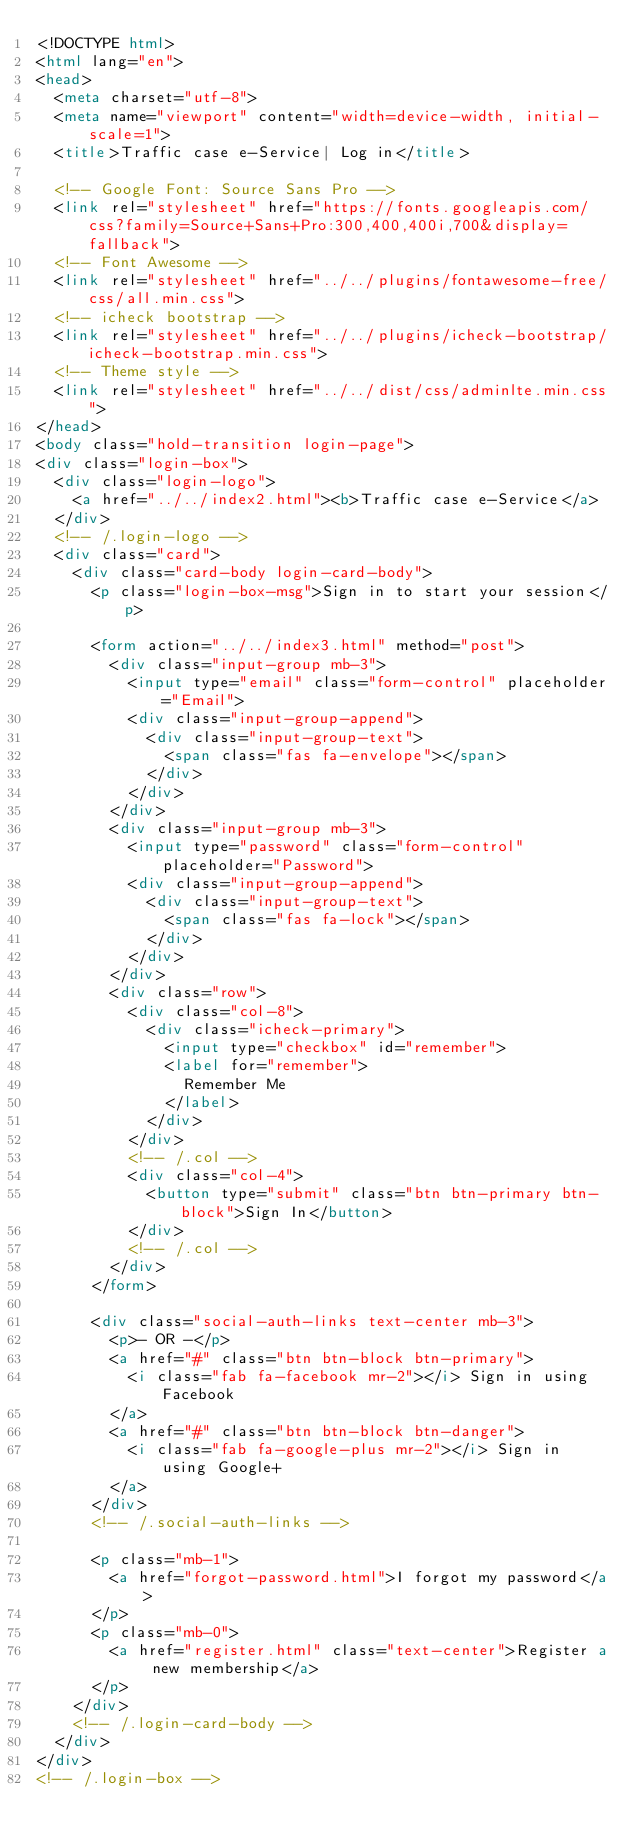<code> <loc_0><loc_0><loc_500><loc_500><_HTML_><!DOCTYPE html>
<html lang="en">
<head>
  <meta charset="utf-8">
  <meta name="viewport" content="width=device-width, initial-scale=1">
  <title>Traffic case e-Service| Log in</title>

  <!-- Google Font: Source Sans Pro -->
  <link rel="stylesheet" href="https://fonts.googleapis.com/css?family=Source+Sans+Pro:300,400,400i,700&display=fallback">
  <!-- Font Awesome -->
  <link rel="stylesheet" href="../../plugins/fontawesome-free/css/all.min.css">
  <!-- icheck bootstrap -->
  <link rel="stylesheet" href="../../plugins/icheck-bootstrap/icheck-bootstrap.min.css">
  <!-- Theme style -->
  <link rel="stylesheet" href="../../dist/css/adminlte.min.css">
</head>
<body class="hold-transition login-page">
<div class="login-box">
  <div class="login-logo">
    <a href="../../index2.html"><b>Traffic case e-Service</a>
  </div>
  <!-- /.login-logo -->
  <div class="card">
    <div class="card-body login-card-body">
      <p class="login-box-msg">Sign in to start your session</p>

      <form action="../../index3.html" method="post">
        <div class="input-group mb-3">
          <input type="email" class="form-control" placeholder="Email">
          <div class="input-group-append">
            <div class="input-group-text">
              <span class="fas fa-envelope"></span>
            </div>
          </div>
        </div>
        <div class="input-group mb-3">
          <input type="password" class="form-control" placeholder="Password">
          <div class="input-group-append">
            <div class="input-group-text">
              <span class="fas fa-lock"></span>
            </div>
          </div>
        </div>
        <div class="row">
          <div class="col-8">
            <div class="icheck-primary">
              <input type="checkbox" id="remember">
              <label for="remember">
                Remember Me
              </label>
            </div>
          </div>
          <!-- /.col -->
          <div class="col-4">
            <button type="submit" class="btn btn-primary btn-block">Sign In</button>
          </div>
          <!-- /.col -->
        </div>
      </form>

      <div class="social-auth-links text-center mb-3">
        <p>- OR -</p>
        <a href="#" class="btn btn-block btn-primary">
          <i class="fab fa-facebook mr-2"></i> Sign in using Facebook
        </a>
        <a href="#" class="btn btn-block btn-danger">
          <i class="fab fa-google-plus mr-2"></i> Sign in using Google+
        </a>
      </div>
      <!-- /.social-auth-links -->

      <p class="mb-1">
        <a href="forgot-password.html">I forgot my password</a>
      </p>
      <p class="mb-0">
        <a href="register.html" class="text-center">Register a new membership</a>
      </p>
    </div>
    <!-- /.login-card-body -->
  </div>
</div>
<!-- /.login-box -->
</code> 